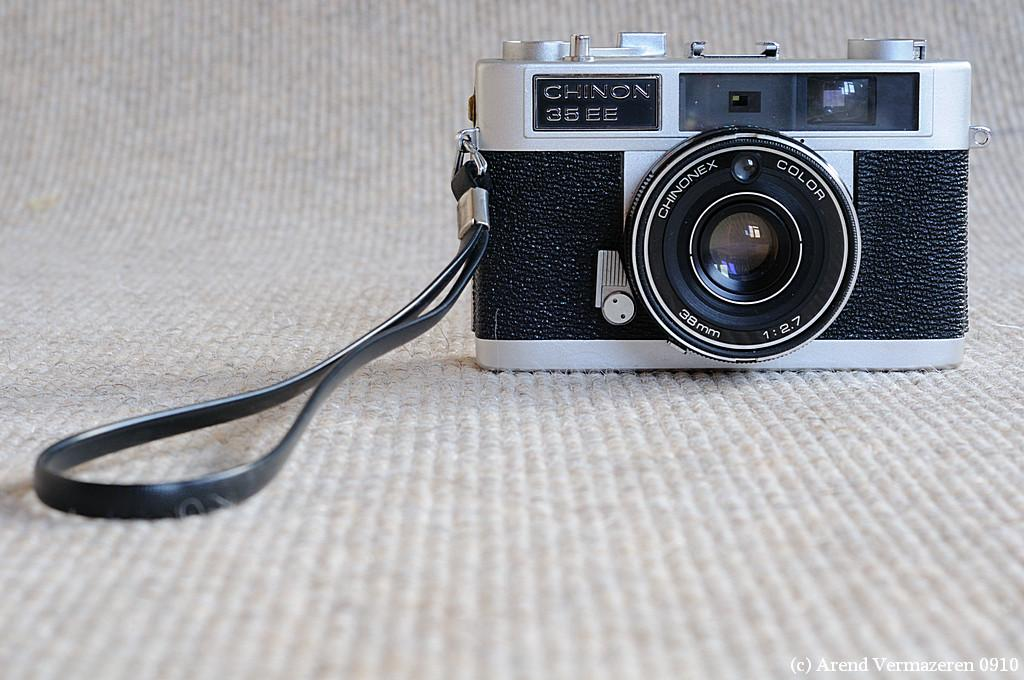What can be found in the bottom right corner of the image? There is a watermark in the bottom right corner of the image. What is the main subject of the image? The main subject of the image is a gray color camera. How is the camera positioned in the image? The camera is arranged on a surface. What is the color of the background in the image? The background of the image is gray in color. What type of bait is being used to catch the clams in the image? There are no clams or bait present in the image; it features a gray color camera on a surface with a gray background. How is the parcel being delivered in the image? There is no parcel present in the image; it only shows a gray color camera on a surface with a gray background. 